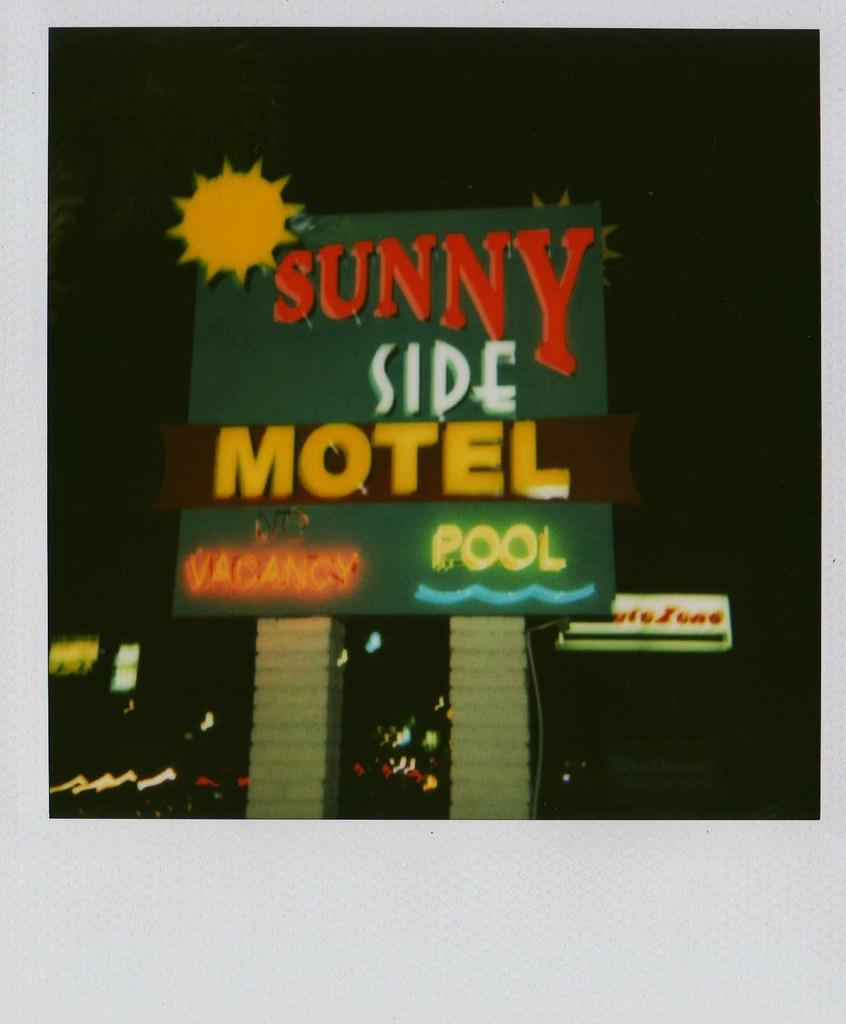What is the main object in the image? There is a board in the image. What is on the board? There is writing on the board. How is the board supported? The board is placed on pillars. Can you see another board in the image? Yes, there is another board in the background of the image. What is the condition of the sky in the image? The sky is dark in the image. How many leaves can be seen on the board in the image? There are no leaves present on the board or in the image. Can you tell me the color of the eye on the board in the image? There is no eye depicted on the board or in the image. 